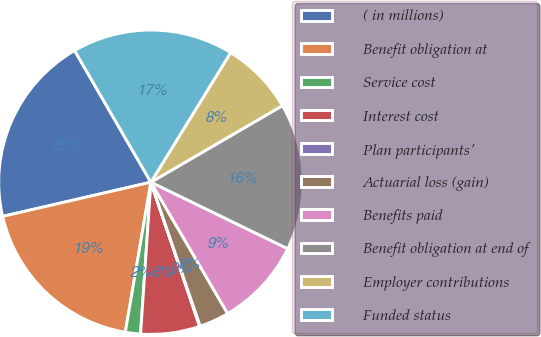Convert chart. <chart><loc_0><loc_0><loc_500><loc_500><pie_chart><fcel>( in millions)<fcel>Benefit obligation at<fcel>Service cost<fcel>Interest cost<fcel>Plan participants'<fcel>Actuarial loss (gain)<fcel>Benefits paid<fcel>Benefit obligation at end of<fcel>Employer contributions<fcel>Funded status<nl><fcel>20.25%<fcel>18.7%<fcel>1.61%<fcel>6.27%<fcel>0.06%<fcel>3.17%<fcel>9.38%<fcel>15.59%<fcel>7.83%<fcel>17.14%<nl></chart> 